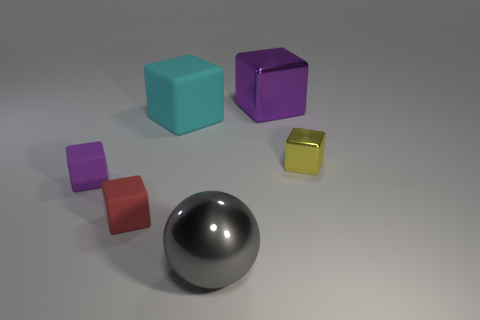How many tiny metal things are there?
Offer a terse response. 1. Do the cyan rubber cube that is in front of the big purple metallic cube and the metallic cube that is behind the yellow metal block have the same size?
Provide a succinct answer. Yes. There is a small shiny object that is the same shape as the large cyan thing; what is its color?
Offer a terse response. Yellow. Does the big cyan object have the same shape as the red matte thing?
Keep it short and to the point. Yes. The red rubber object that is the same shape as the tiny purple matte thing is what size?
Offer a terse response. Small. How many tiny red cubes are the same material as the tiny purple object?
Offer a terse response. 1. How many objects are either red matte cubes or purple metallic blocks?
Give a very brief answer. 2. There is a rubber thing that is behind the yellow metal object; is there a big gray metallic sphere behind it?
Ensure brevity in your answer.  No. Is the number of red matte blocks that are behind the large purple metallic object greater than the number of large cyan rubber blocks in front of the large metallic ball?
Provide a short and direct response. No. What material is the other block that is the same color as the large shiny block?
Provide a succinct answer. Rubber. 